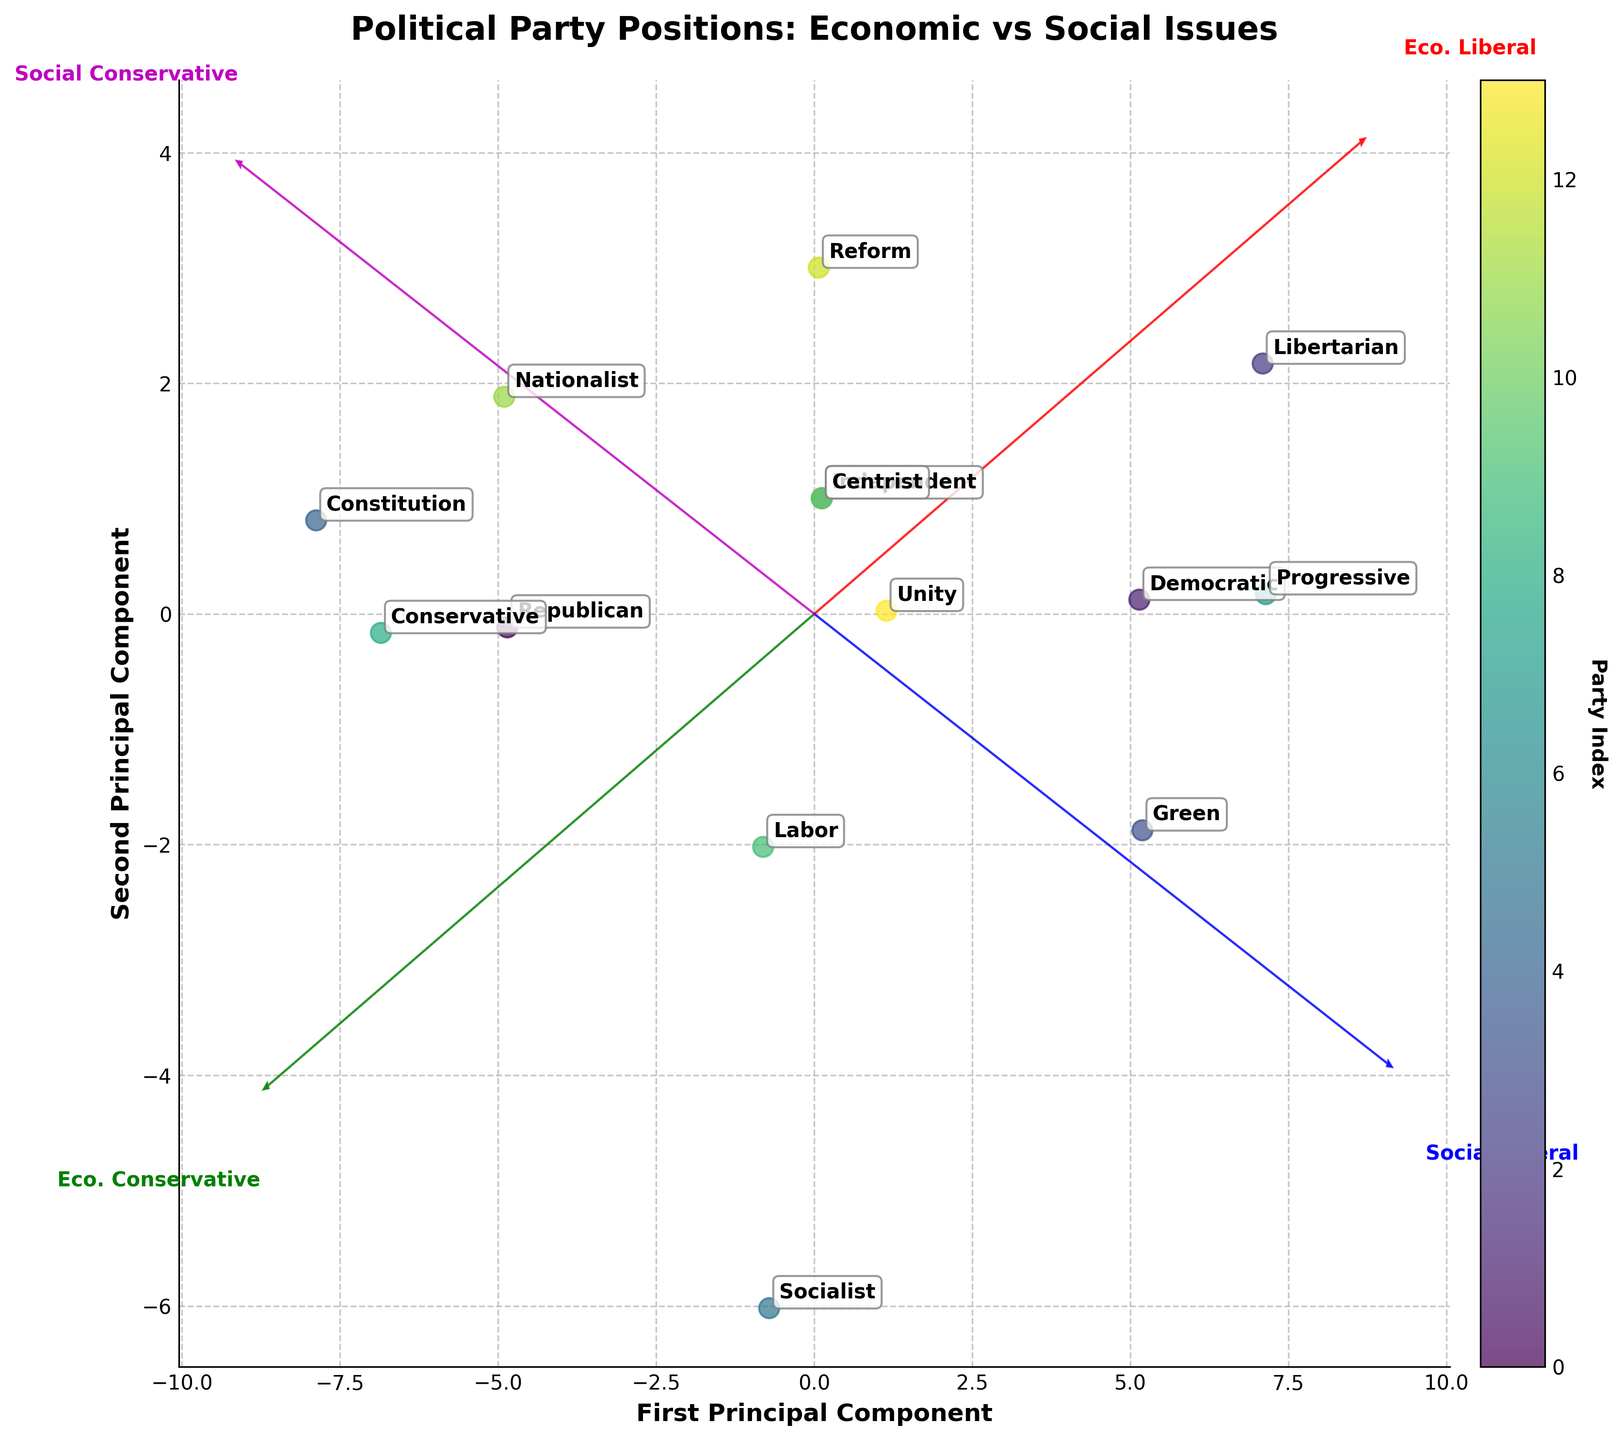What is the title of the plot? The title of the plot is displayed at the top and is larger and bold compared to other text elements in the plot.
Answer: Political Party Positions: Economic vs Social Issues How many political parties are represented in the plot? The number of data points in the plot corresponds to the number of political parties, each labeled with a party's name. Counting these labels gives the total number of parties. There are 14 distinct data points represented by different colors.
Answer: 14 Which party is positioned closest to the center of the plot? Identify the data point that is nearest to the origin (0,0) in the plot. By visually inspecting the plot, the party "Independent" appears to be closest to the center.
Answer: Independent How do the economic and social liberal values of the Progressive party compare to the Libertarian party? Locate the positions of the Progressive and Libertarian parties on the plot and compare their coordinates. The Progressive party is plotted near (8,2) and the Libertarian near (9,2), both indicating high values in economic and social liberalism. There is a slight difference in economic liberalism, but their social values are nearly identical.
Answer: Progressive has slightly lower economic liberalism but similar social liberalism compared to Libertarian Which feature vector (axis) indicates Economic Liberal values? The feature vectors are labeled around the periphery of the plot in colored text. The arrow pointing towards "Eco. Liberal" in red represents Economic Liberal values.
Answer: The red arrow labeled "Eco. Liberal" Which party shows the maximum convergence on Economic Conservative and Social Conservative dimensions? Locate the data point that is farthest along both the economic conservative and social conservative feature vectors. The Constitution party is positioned farthest in both these dimensions, indicating maximum convergence.
Answer: Constitution Identify the party that has a significant liberal stance with minimal conservative alignment? Look for parties placed near the edges of liberal feature vectors (both economic and social) and far from conservative vectors. The Progressive party is significantly aligned with liberal values and minimally with conservative ones.
Answer: Progressive Of the parties listed, which two are identically placed in the plot? Identify any overlapping points or entries with identical coordinates. The Independent and Centrist parties share the same coordinates, suggesting identical political stances.
Answer: Independent and Centrist Compare the Principal Component scores of the Republican and Democratic parties. Which party is more conservative overall? The position of the Republican party reflects higher scores along the economic and social conservative dimensions compared to the Democratic party, which shows higher scores in liberal dimensions. Hence, the Republican party is overall more conservative.
Answer: Republican Based on the plot, which party is an outlier, and why? An outlier would be a party that significantly deviates from the clustering of the majority of parties. The Constitution party is far removed towards the economic and social conservative axes, making it distinctly separate from most parties, thereby an outlier.
Answer: Constitution 